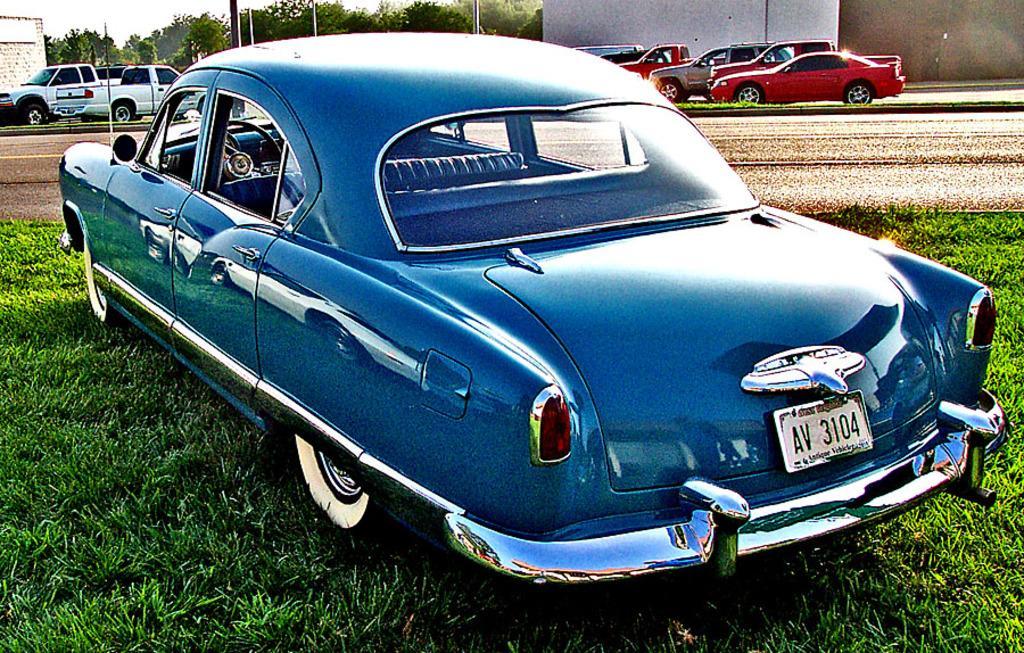Please provide a concise description of this image. In this image I can see some grass on the ground and a car which is blue in color on the ground. In the background I can see the road, few vehicles on the road, few trees, few buildings and the sky. 